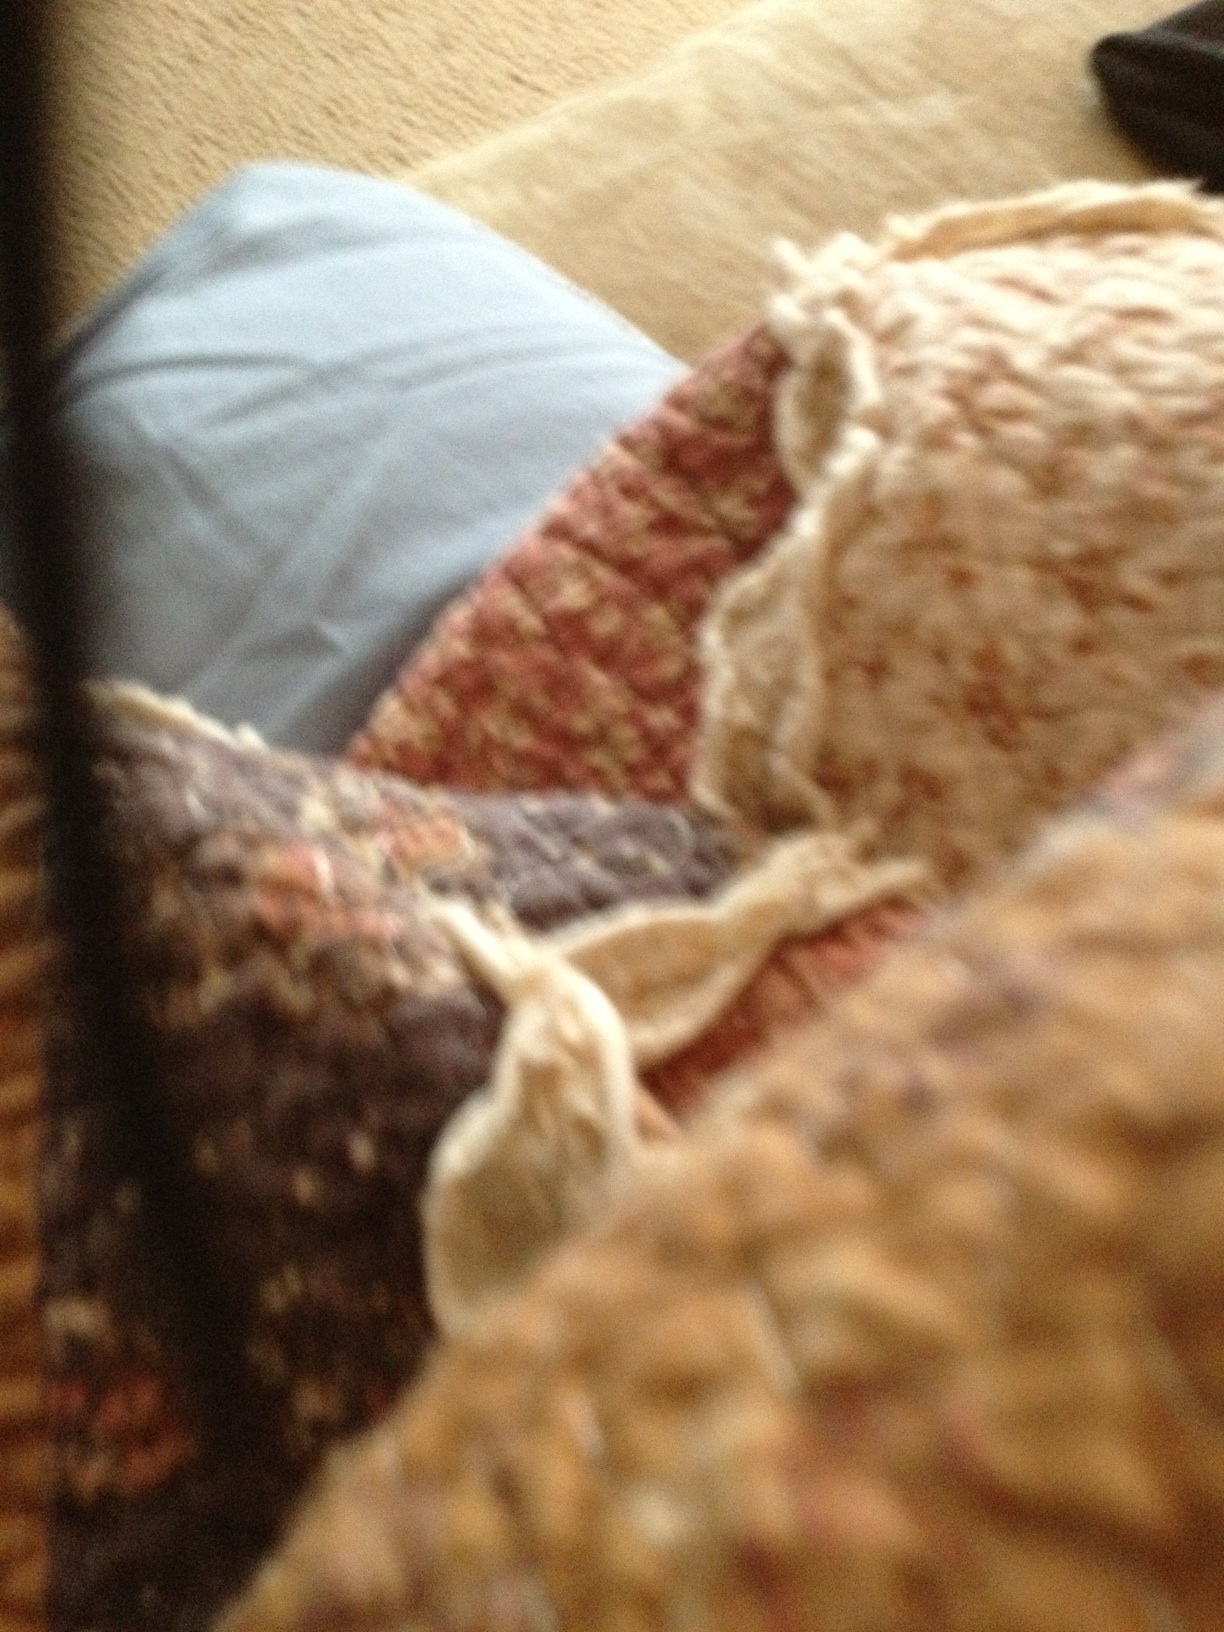What colors are in this material? The material in the image displays a variety of colors, including burgundy red, cream, and elements of blue. These colors are woven together in a textured pattern that adds depth to the fabric. 